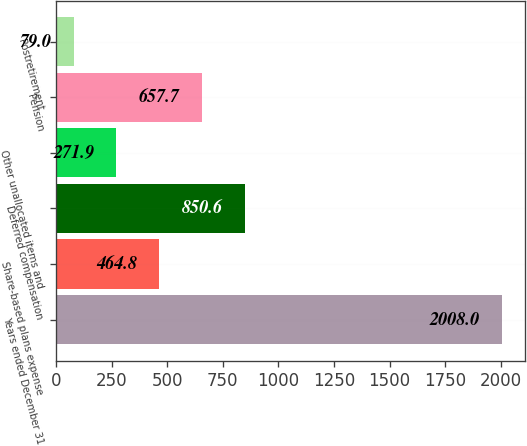Convert chart to OTSL. <chart><loc_0><loc_0><loc_500><loc_500><bar_chart><fcel>Years ended December 31<fcel>Share-based plans expense<fcel>Deferred compensation<fcel>Other unallocated items and<fcel>Pension<fcel>Postretirement<nl><fcel>2008<fcel>464.8<fcel>850.6<fcel>271.9<fcel>657.7<fcel>79<nl></chart> 